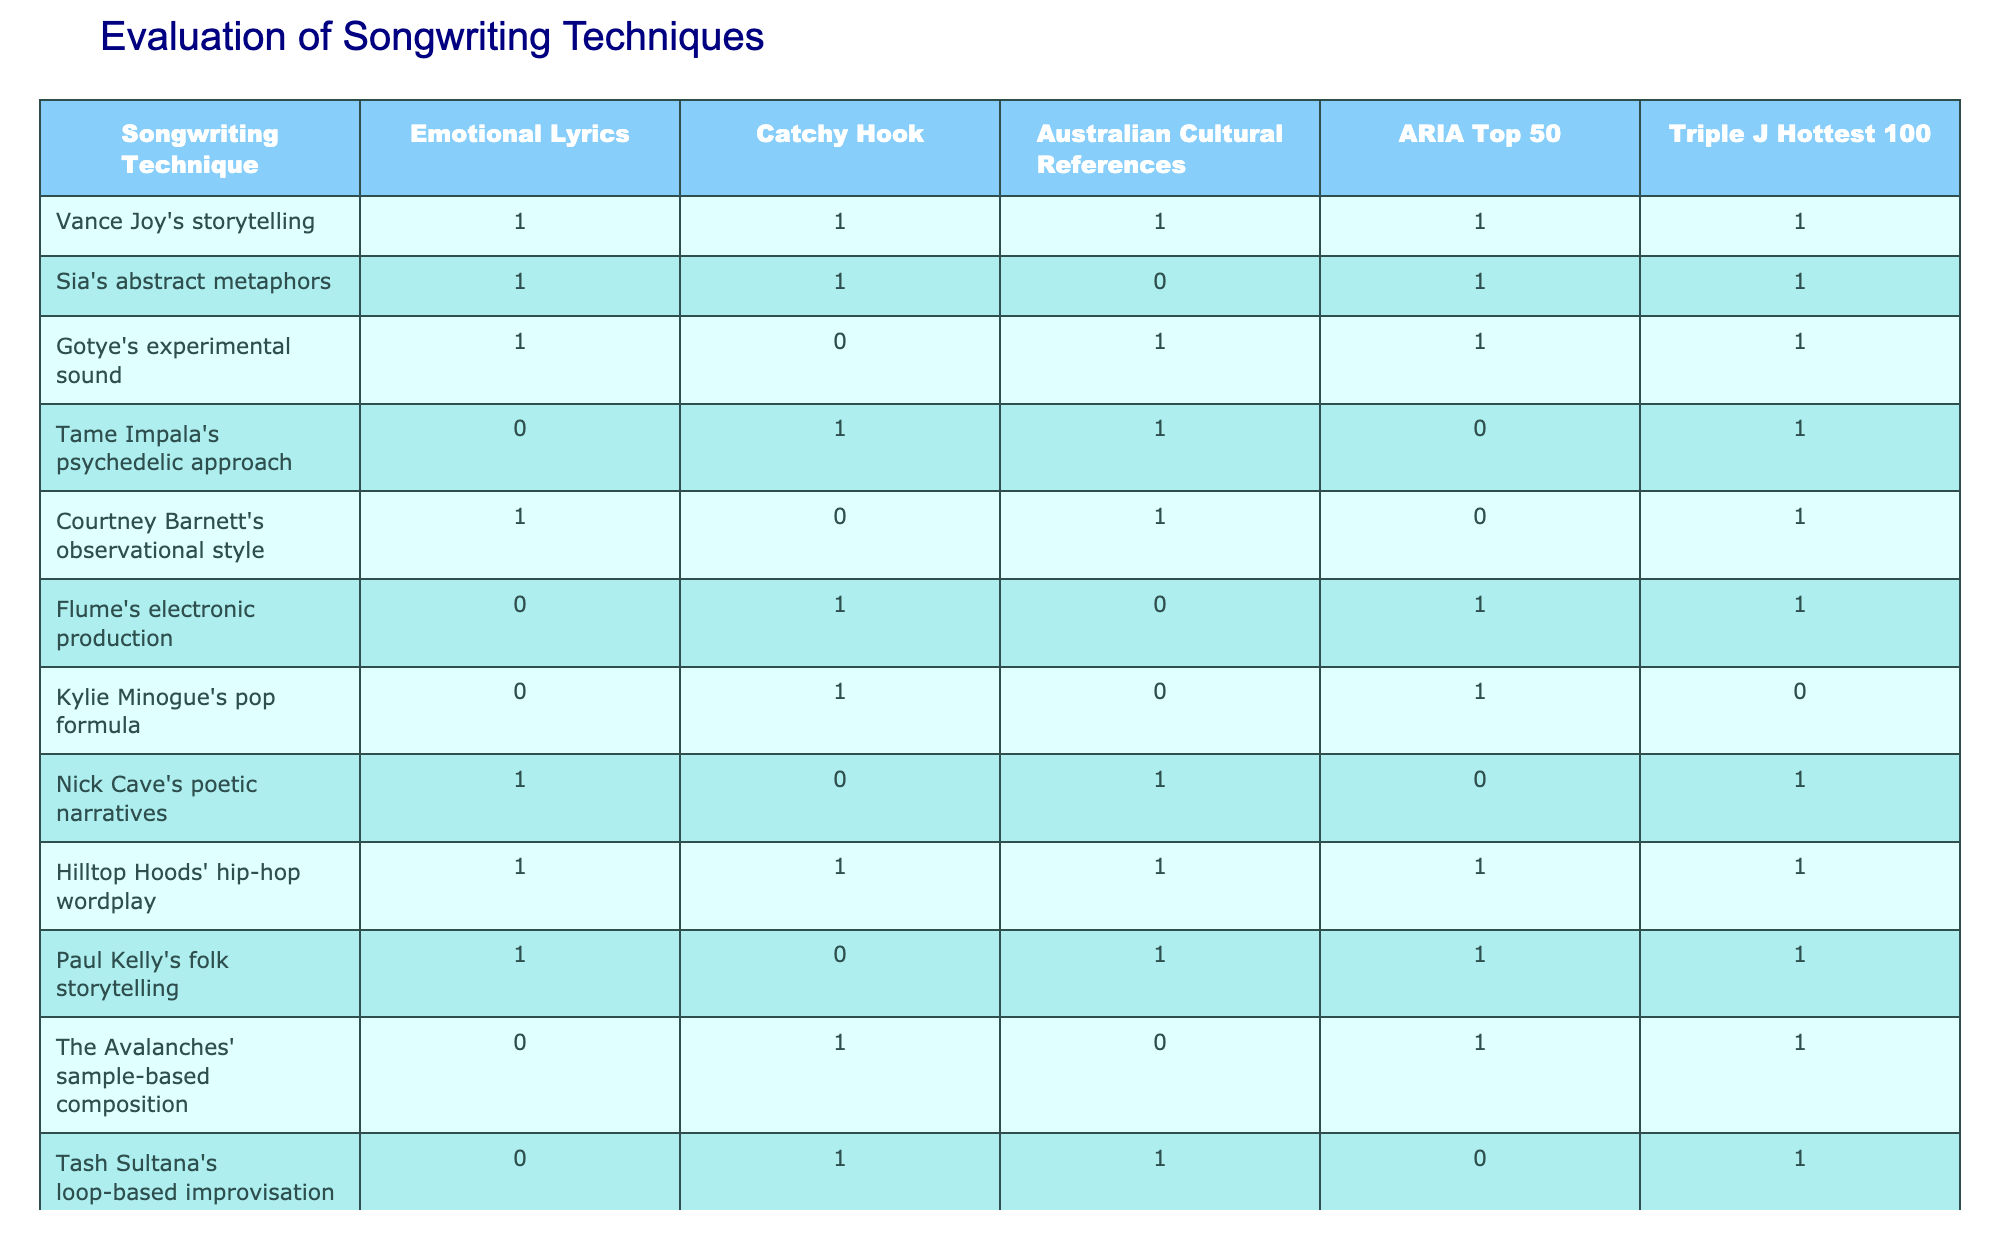What percentage of songs include emotional lyrics? There are a total of 13 songs in the table. Out of these, 9 songs have emotional lyrics (indicated by a 1 in the Emotional Lyrics column). To find the percentage, we use the formula: (Number of songs with emotional lyrics / Total number of songs) * 100. Thus, (9 / 13) * 100 = approximately 69.23%.
Answer: 69.23% Which songwriting technique has no catchy hook but includes emotional lyrics? By inspecting the table, we see that Courtney Barnett's observational style (1 in Emotional Lyrics, 0 in Catchy Hook) fits this criteria.
Answer: Courtney Barnett's observational style How many songs reference Australian culture? We need to count the number of songs where Australian Cultural References is equal to 1. There are 7 songs (Vance Joy's storytelling, Gotye's experimental sound, Courtney Barnett's observational style, Hilltop Hoods' hip-hop wordplay, Paul Kelly's folk storytelling, Crowded House's melodic harmonies) where this is true.
Answer: 7 Is Tame Impala's approach successful in the ARIA Top 50? Looking at the ARIA Top 50 column for Tame Impala's psychedelic approach, it has a value of 0, indicating it did not perform well in this chart.
Answer: No How many songs by artists with a catchy hook also appeared in the Triple J Hottest 100? First, we identify the songs with a catchy hook (value of 1 in Catchy Hook) which are Vance Joy's storytelling, Sia's abstract metaphors, Tame Impala's psychedelic approach, Hilltop Hoods' hip-hop wordplay, Flume's electronic production, Kylie Minogue's pop formula, Crowded House's melodic harmonies. Out of these, we see that 4 songs (Vance Joy's storytelling, Sia's abstract metaphors, Hilltop Hoods' hip-hop wordplay, Crowded House's melodic harmonies) made it into the Triple J Hottest 100 (value of 1).
Answer: 4 Which two artists have the most similar characteristics in terms of emotional lyrics and catchy hook? By comparing the values, we see that Vance Joy and Hilltop Hoods both have a 1 for emotional lyrics and a 1 for catchy hook. This indicates they share the same successful songwriting characteristics according to the table.
Answer: Vance Joy and Hilltop Hoods 